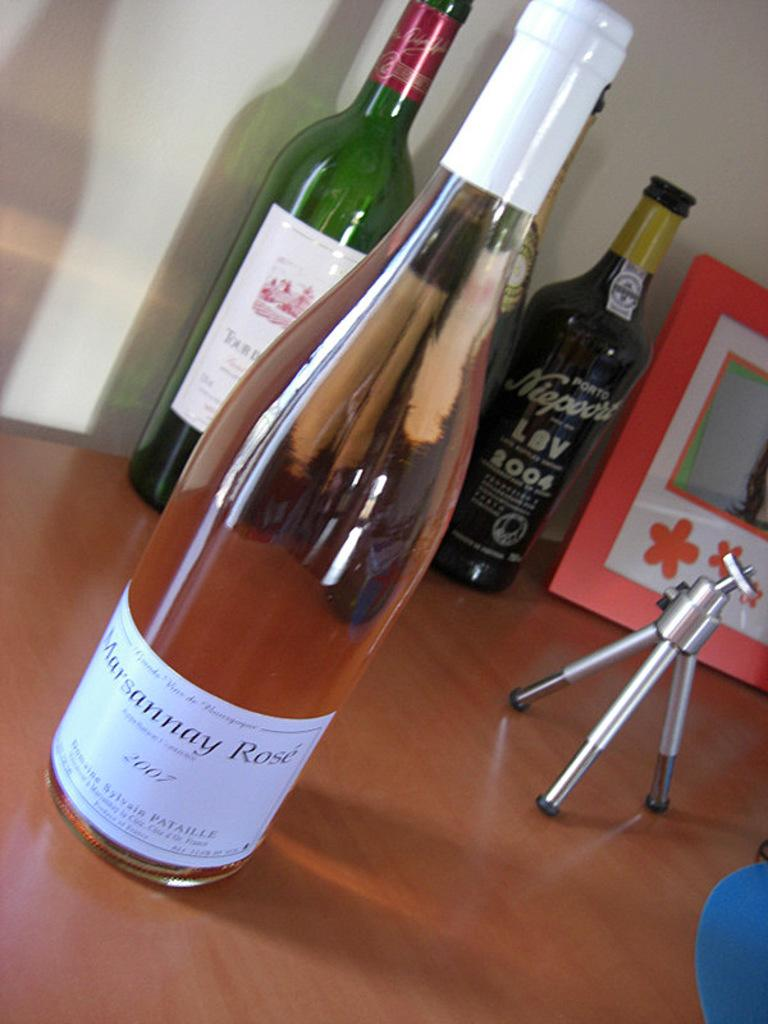How many bottles are visible in the image? There are four bottles in the image. What distinguishes the bottles from one another? The bottles have different colors and stickers on them. What type of structure is present in the image? There is a frame in the image. What is used to hold the bottles in the image? There is a stand in the image that holds the bottles. What type of furniture is present in the image? The wooden table is present in the image. Can you see any legs in the image? There are no legs visible in the image. What type of animals can be seen in the bedroom in the image? There is no bedroom or animals present in the image. 